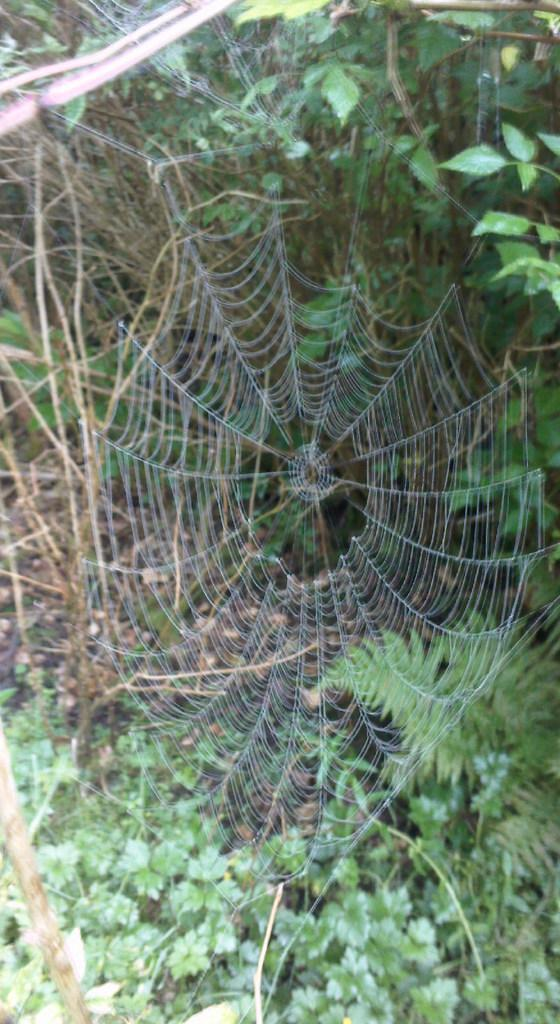What is the main subject of the image? The main subject of the image is a spider web. What can be seen in the background of the image? There are trees and plants in the background of the image. What is the rate at which the spider web is expanding in the image? There is no indication of the spider web expanding in the image, so it is not possible to determine a rate. 